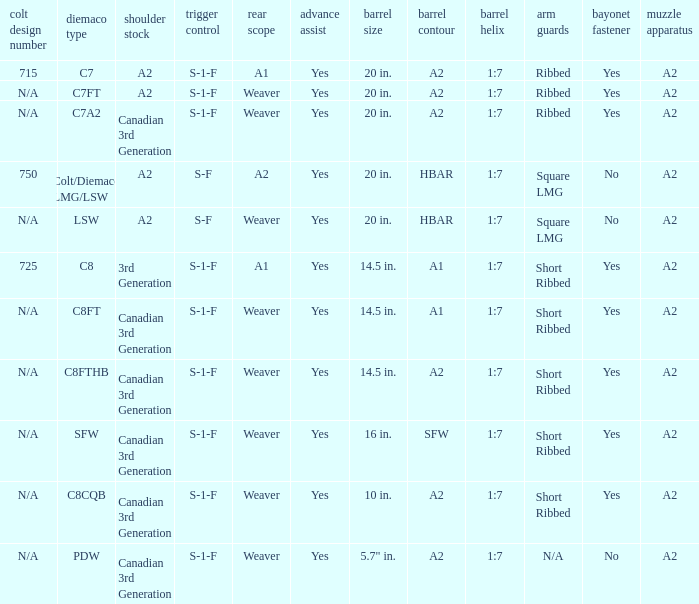Which barrel twist includes a 3rd generation canadian stock and short ribbed hand guards? 1:7, 1:7, 1:7, 1:7. 